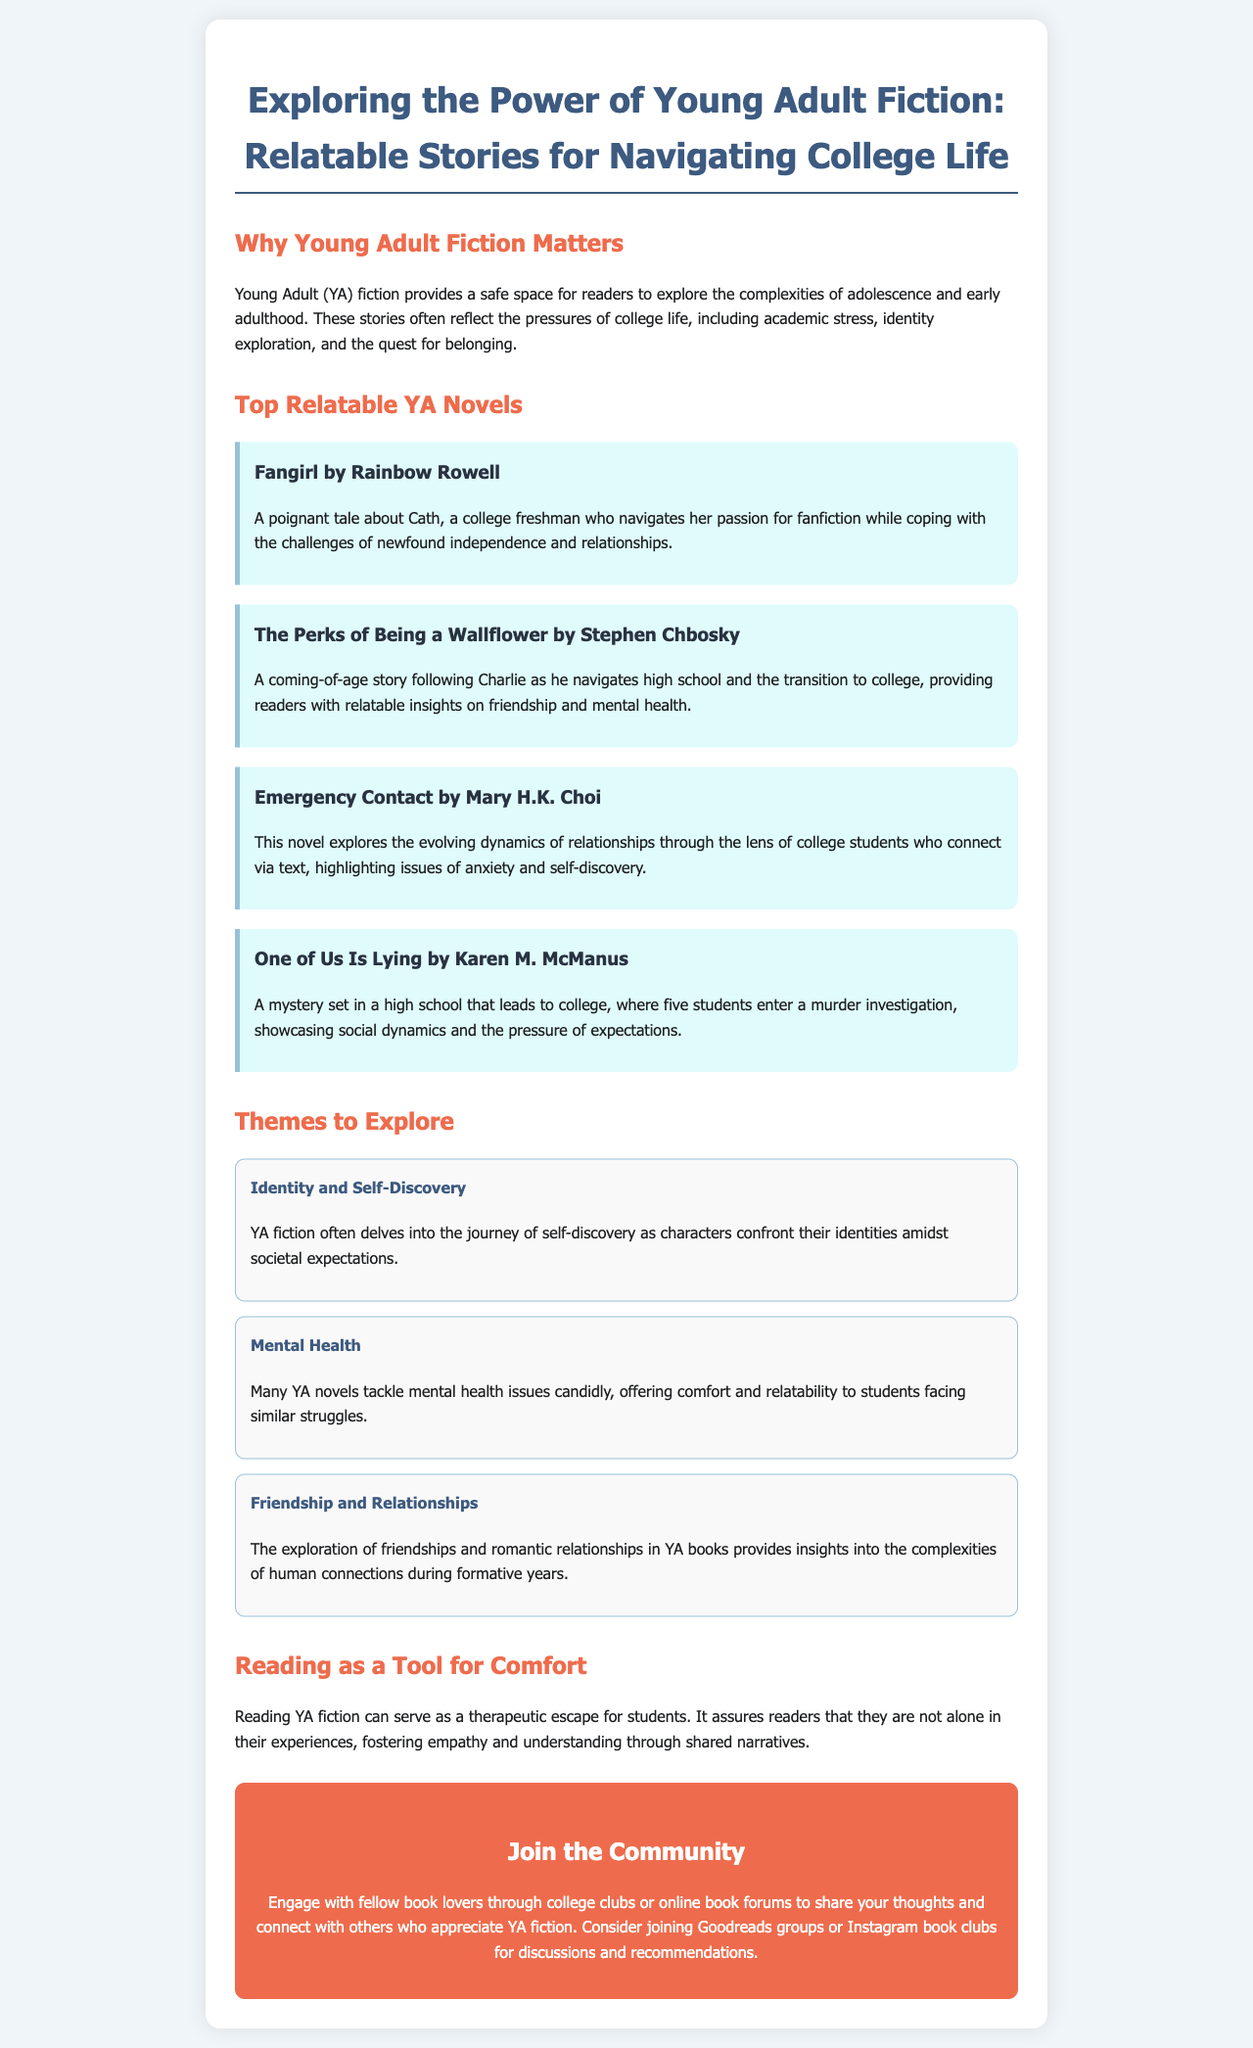What is the title of the brochure? The title of the brochure is prominently displayed at the top of the document.
Answer: Exploring the Power of Young Adult Fiction: Relatable Stories for Navigating College Life Who is the author of "Fangirl"? The brochure lists the author of this book in the description.
Answer: Rainbow Rowell What theme does the brochure highlight that relates to college struggles? The document discusses various themes that are prevalent in YA fiction.
Answer: Mental Health How many top relatable YA novels are mentioned? The brochure lists a specific number of novels in a section.
Answer: Four What is one way students can engage with fellow book lovers? The document suggests specific avenues for engagement in the community section.
Answer: College clubs Which book is described as a mystery involving a murder investigation? The document contains a description of this book among the listed novels.
Answer: One of Us Is Lying What does YA fiction offer readers, according to the brochure? The document explains a broader benefit of reading YA fiction for students.
Answer: Comfort and relatability What is a key detail about the book "Emergency Contact"? The brochure provides a brief overview of the book's plot.
Answer: Connect via text 